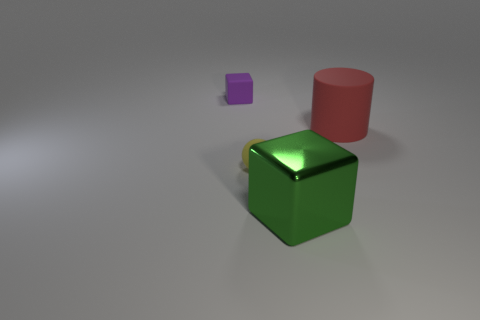Subtract 1 blocks. How many blocks are left? 1 Add 1 rubber objects. How many objects exist? 5 Subtract 0 cyan cubes. How many objects are left? 4 Subtract all balls. How many objects are left? 3 Subtract all yellow cubes. Subtract all gray cylinders. How many cubes are left? 2 Subtract all large red cylinders. Subtract all green things. How many objects are left? 2 Add 1 green cubes. How many green cubes are left? 2 Add 1 big brown metallic balls. How many big brown metallic balls exist? 1 